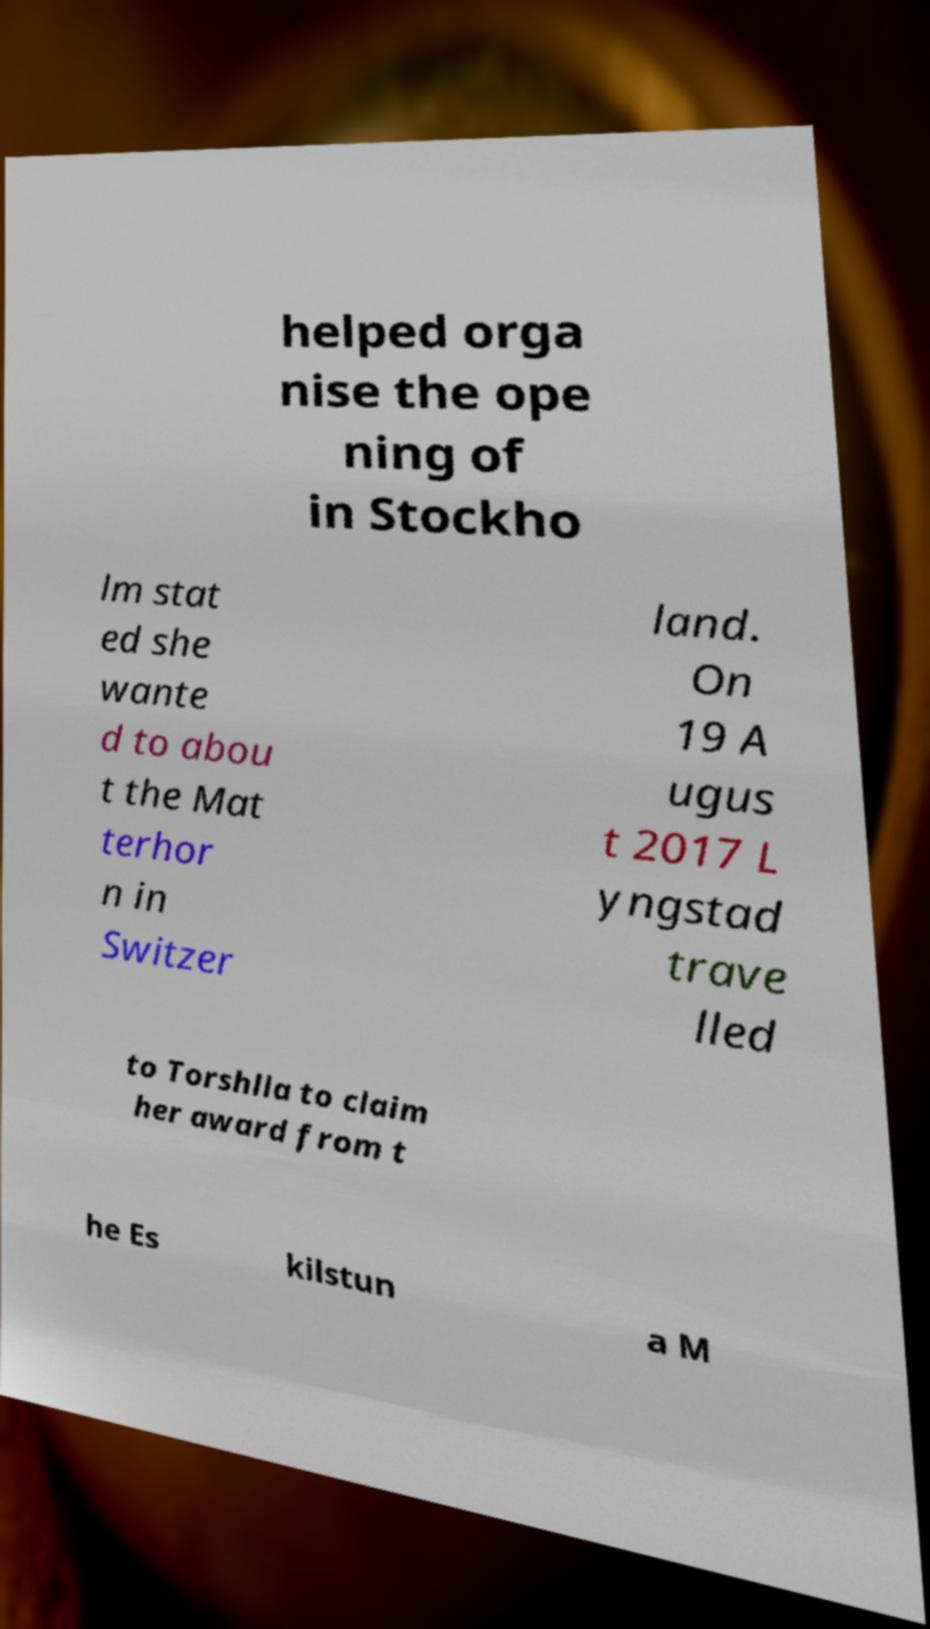What messages or text are displayed in this image? I need them in a readable, typed format. helped orga nise the ope ning of in Stockho lm stat ed she wante d to abou t the Mat terhor n in Switzer land. On 19 A ugus t 2017 L yngstad trave lled to Torshlla to claim her award from t he Es kilstun a M 